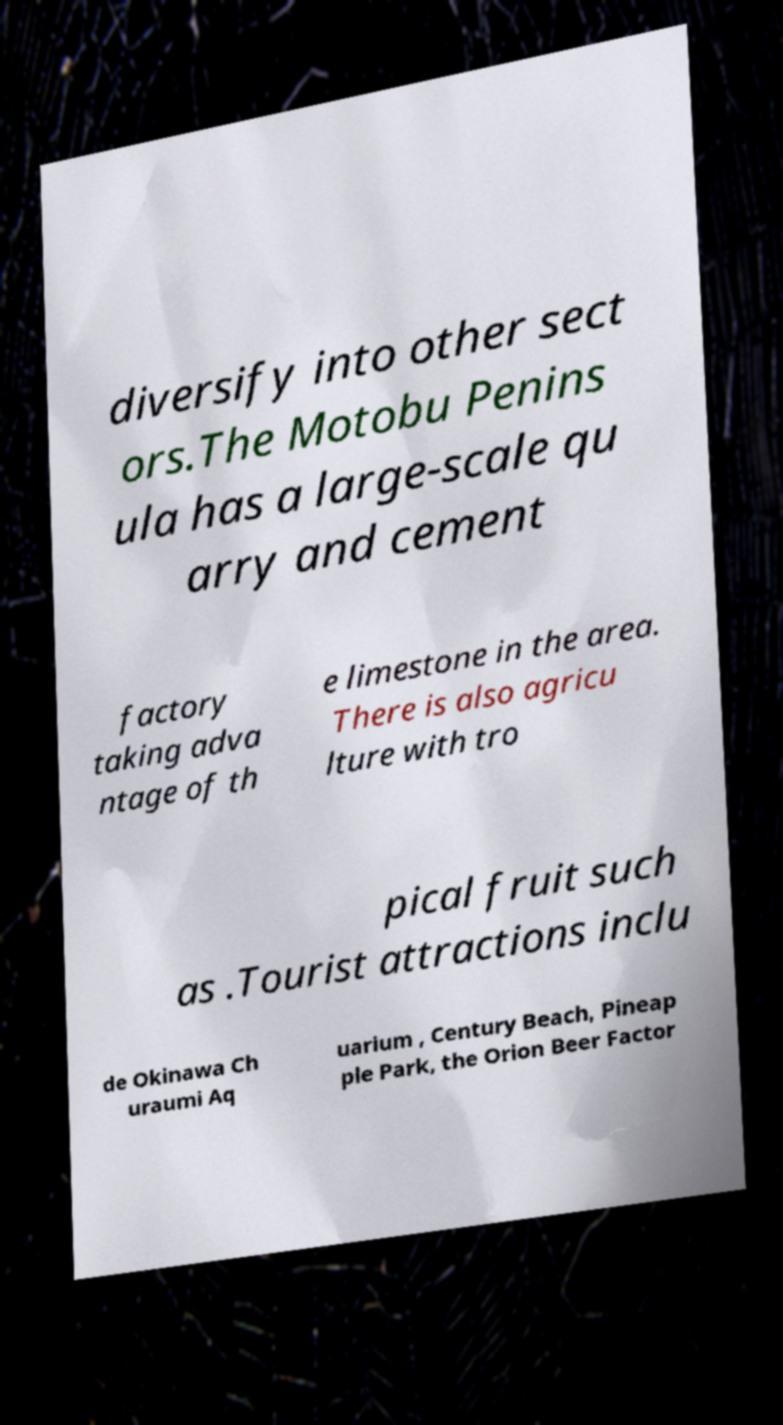Can you read and provide the text displayed in the image?This photo seems to have some interesting text. Can you extract and type it out for me? diversify into other sect ors.The Motobu Penins ula has a large-scale qu arry and cement factory taking adva ntage of th e limestone in the area. There is also agricu lture with tro pical fruit such as .Tourist attractions inclu de Okinawa Ch uraumi Aq uarium , Century Beach, Pineap ple Park, the Orion Beer Factor 